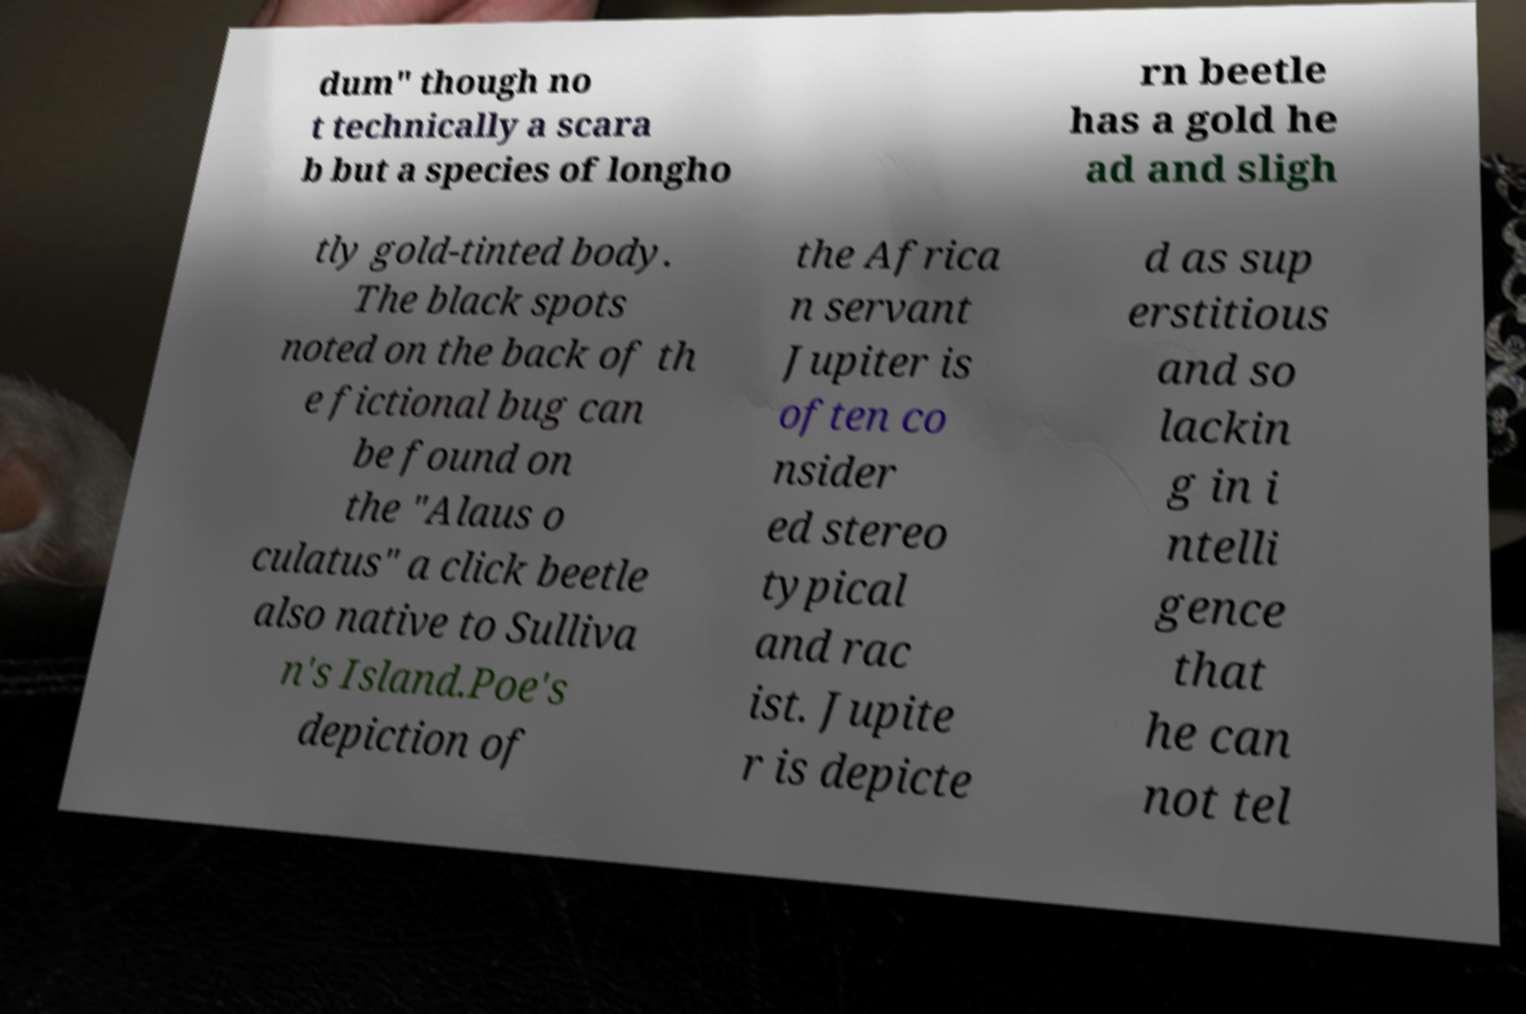For documentation purposes, I need the text within this image transcribed. Could you provide that? dum" though no t technically a scara b but a species of longho rn beetle has a gold he ad and sligh tly gold-tinted body. The black spots noted on the back of th e fictional bug can be found on the "Alaus o culatus" a click beetle also native to Sulliva n's Island.Poe's depiction of the Africa n servant Jupiter is often co nsider ed stereo typical and rac ist. Jupite r is depicte d as sup erstitious and so lackin g in i ntelli gence that he can not tel 